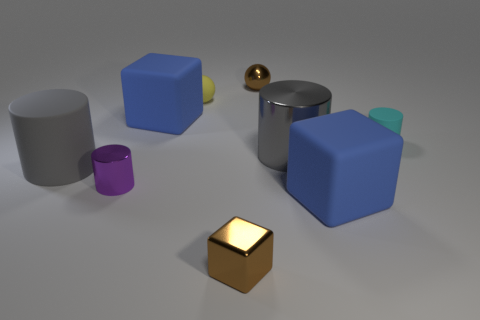Does the brown metallic block that is right of the tiny yellow object have the same size as the blue cube in front of the small cyan rubber thing?
Provide a succinct answer. No. What is the shape of the blue object that is behind the small purple cylinder left of the large blue thing to the right of the yellow rubber object?
Ensure brevity in your answer.  Cube. Is there any other thing that has the same material as the yellow sphere?
Ensure brevity in your answer.  Yes. There is a brown metal thing that is the same shape as the yellow rubber object; what size is it?
Ensure brevity in your answer.  Small. What color is the object that is behind the tiny matte cylinder and in front of the tiny yellow ball?
Ensure brevity in your answer.  Blue. Does the small purple cylinder have the same material as the large blue thing that is in front of the tiny cyan rubber cylinder?
Offer a terse response. No. Is the number of tiny rubber objects left of the small purple thing less than the number of tiny cyan things?
Offer a terse response. Yes. How many other things are there of the same shape as the tiny purple thing?
Your answer should be very brief. 3. Is there anything else that is the same color as the tiny shiny sphere?
Keep it short and to the point. Yes. There is a big metal cylinder; is it the same color as the large rubber thing that is on the right side of the small brown ball?
Give a very brief answer. No. 